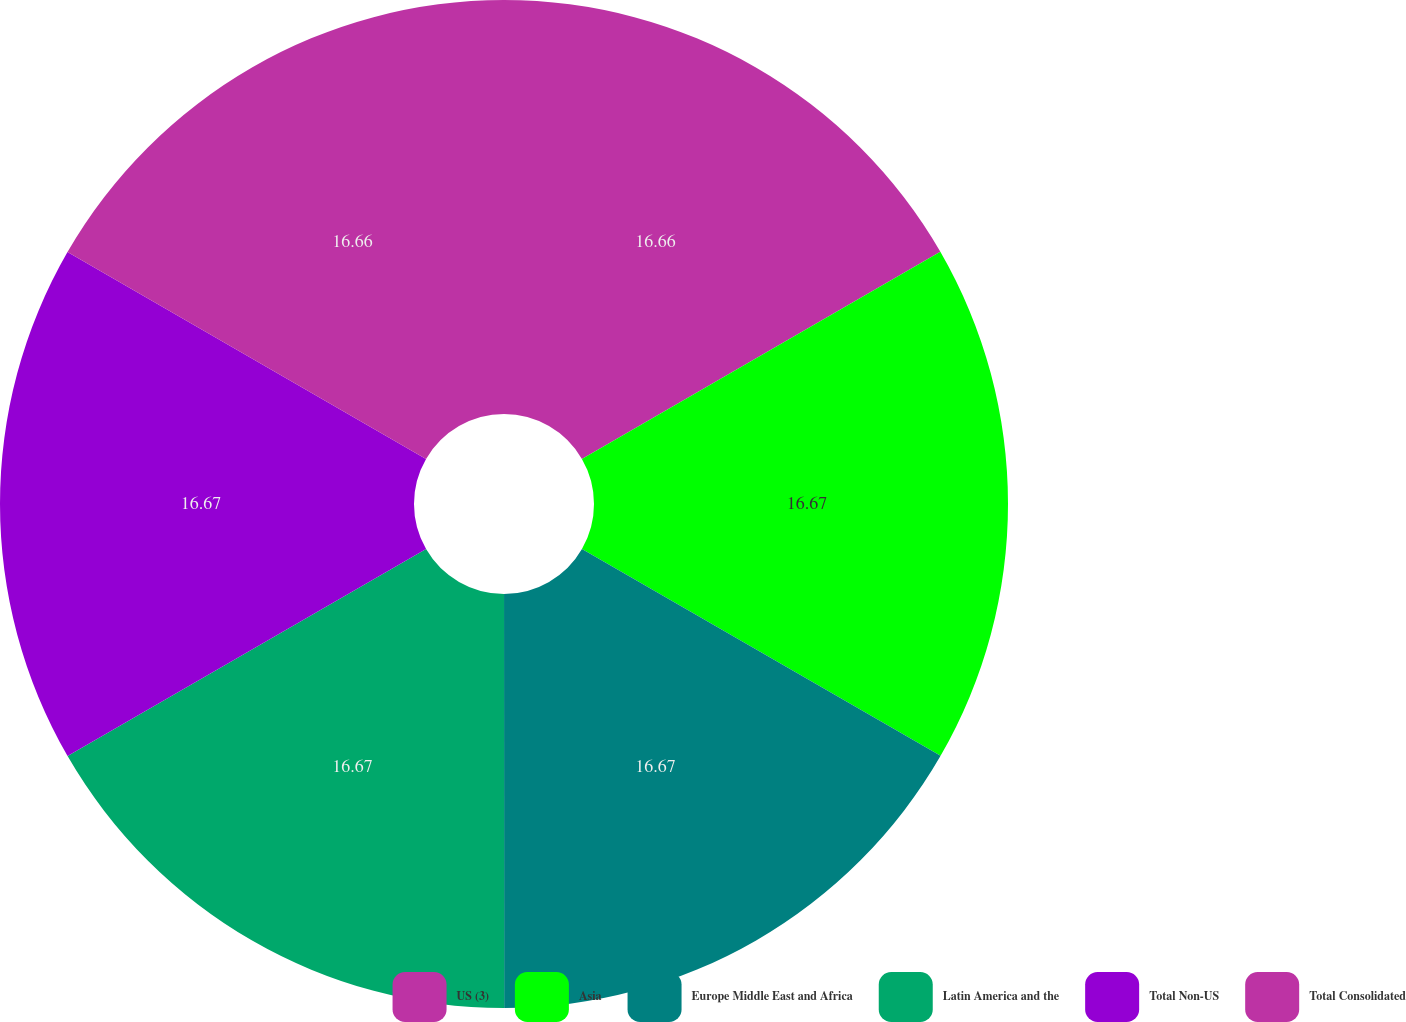Convert chart to OTSL. <chart><loc_0><loc_0><loc_500><loc_500><pie_chart><fcel>US (3)<fcel>Asia<fcel>Europe Middle East and Africa<fcel>Latin America and the<fcel>Total Non-US<fcel>Total Consolidated<nl><fcel>16.66%<fcel>16.67%<fcel>16.67%<fcel>16.67%<fcel>16.67%<fcel>16.67%<nl></chart> 